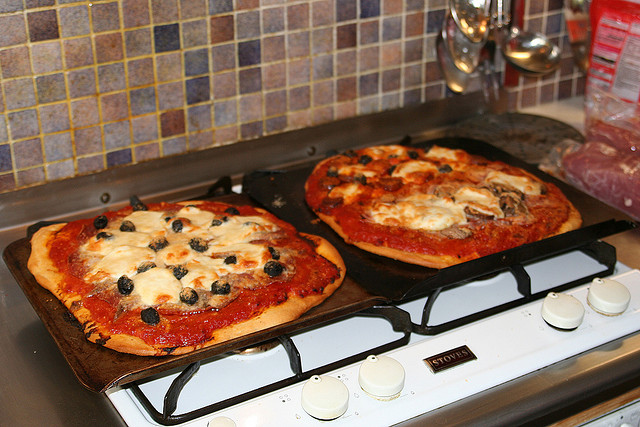Read and extract the text from this image. STOVES 